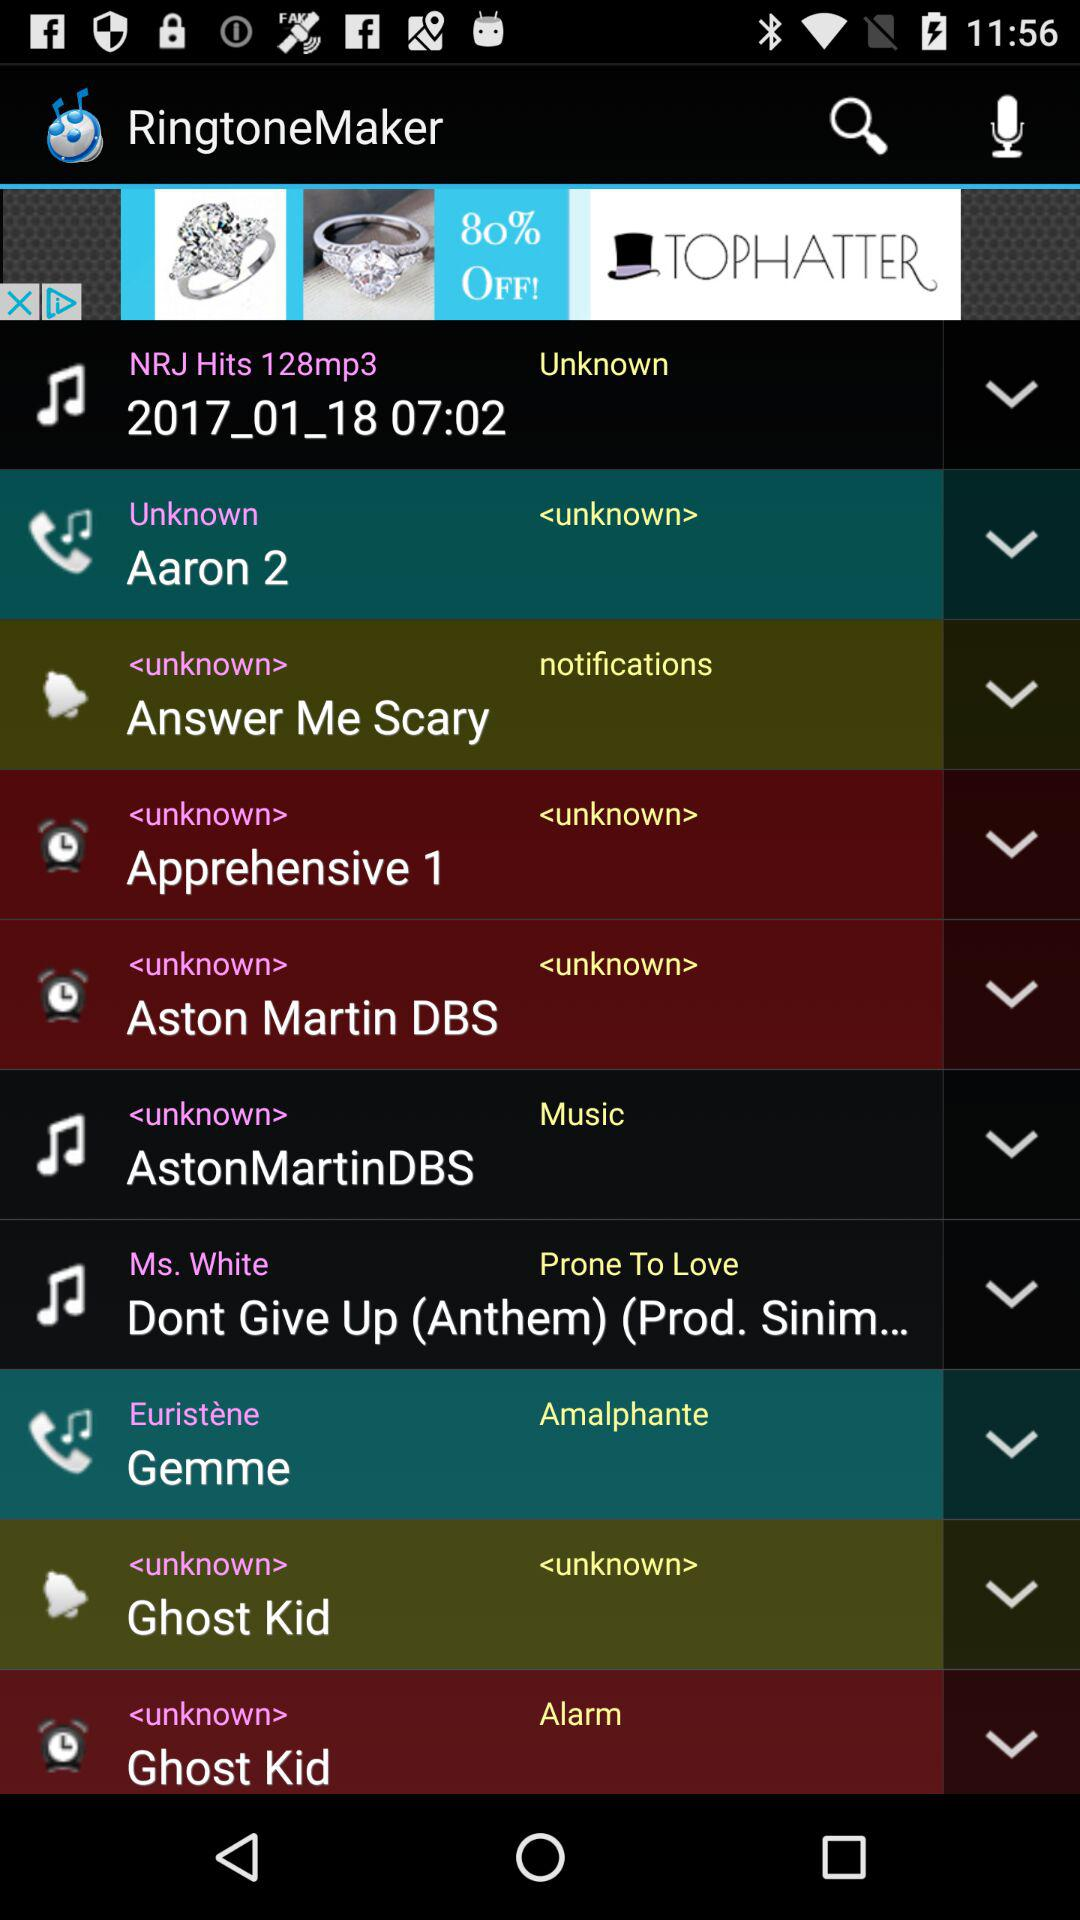What ringtone is set for the alarm? The ringtone is "Ghost Kid". 